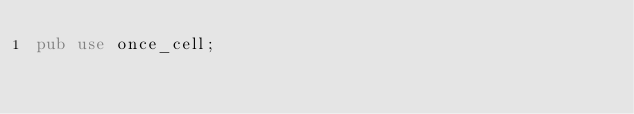Convert code to text. <code><loc_0><loc_0><loc_500><loc_500><_Rust_>pub use once_cell;
</code> 